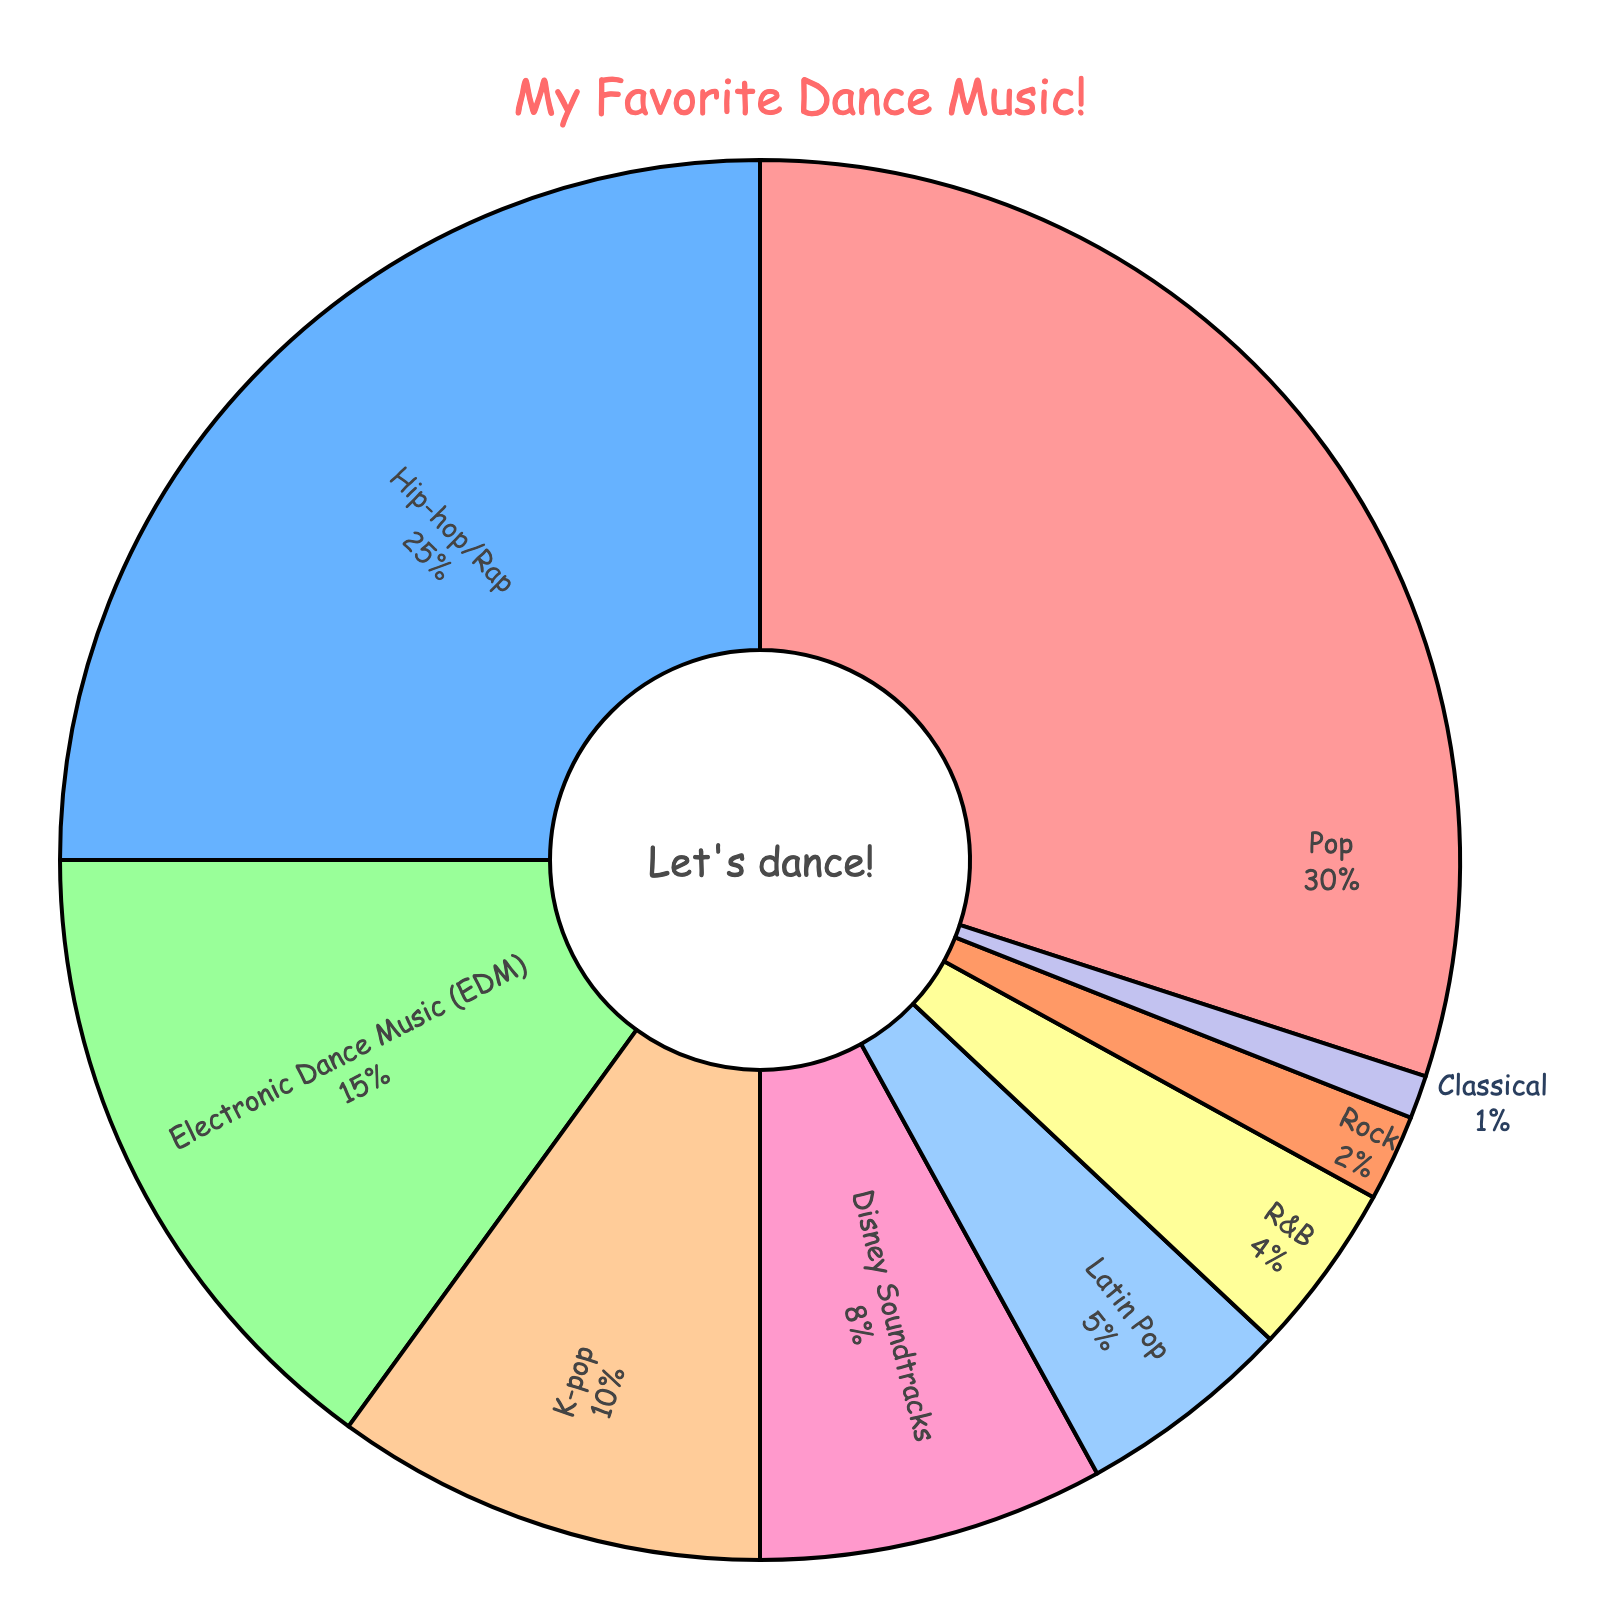Which music genre is the most popular among young dancers? The chart shows that the largest slice is labeled "Pop" with 30%, indicating it is the most popular genre.
Answer: Pop What percentage of young dancers prefer Disney Soundtracks or Rock? Add the percentages of Disney Soundtracks (8%) and Rock (2%), which gives us 8% + 2% = 10%.
Answer: 10% Which is more popular among young dancers, EDM or Hip-hop/Rap? The slice labeled "Hip-hop/Rap" is larger at 25% compared to "Electronic Dance Music (EDM)" at 15%, so Hip-hop/Rap is more popular.
Answer: Hip-hop/Rap How does the preference for Latin Pop compare to K-pop? The chart shows that Latin Pop has 5% while K-pop has 10%. K-pop is twice as popular as Latin Pop.
Answer: K-pop What is the combined percentage for genres with less than 5% preference? The genres Rock (2%), Classical (1%), and R&B (4%) meet this criterion. Their combined percentage is 2% + 1% + 4% = 7%.
Answer: 7% Which genre has the smallest slice in the pie chart? The smallest slice corresponds to the genre labeled "Classical" with 1%.
Answer: Classical If you combined the percentages of Hip-hop/Rap and Pop, how much of the chart would they cover? Pop is 30% and Hip-hop/Rap is 25%. Combined, these cover 30% + 25% = 55% of the chart.
Answer: 55% What is the percentage difference between the preferences for Pop and Disney Soundtracks? The difference is found by subtracting the percentage of Disney Soundtracks (8%) from Pop (30%), giving 30% - 8% = 22%.
Answer: 22% 